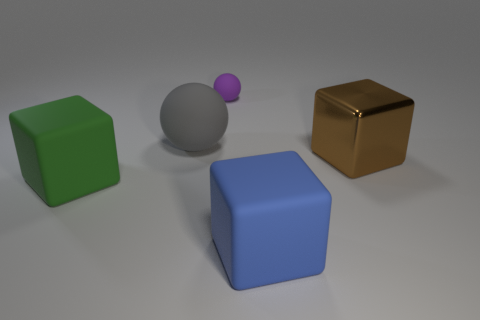Subtract all green rubber cubes. How many cubes are left? 2 Add 1 tiny things. How many objects exist? 6 Subtract all gray balls. How many balls are left? 1 Subtract all cubes. How many objects are left? 2 Subtract 2 cubes. How many cubes are left? 1 Subtract all red balls. Subtract all brown cubes. How many balls are left? 2 Subtract all blue metal objects. Subtract all large gray rubber balls. How many objects are left? 4 Add 1 shiny blocks. How many shiny blocks are left? 2 Add 4 big gray matte spheres. How many big gray matte spheres exist? 5 Subtract 1 purple balls. How many objects are left? 4 